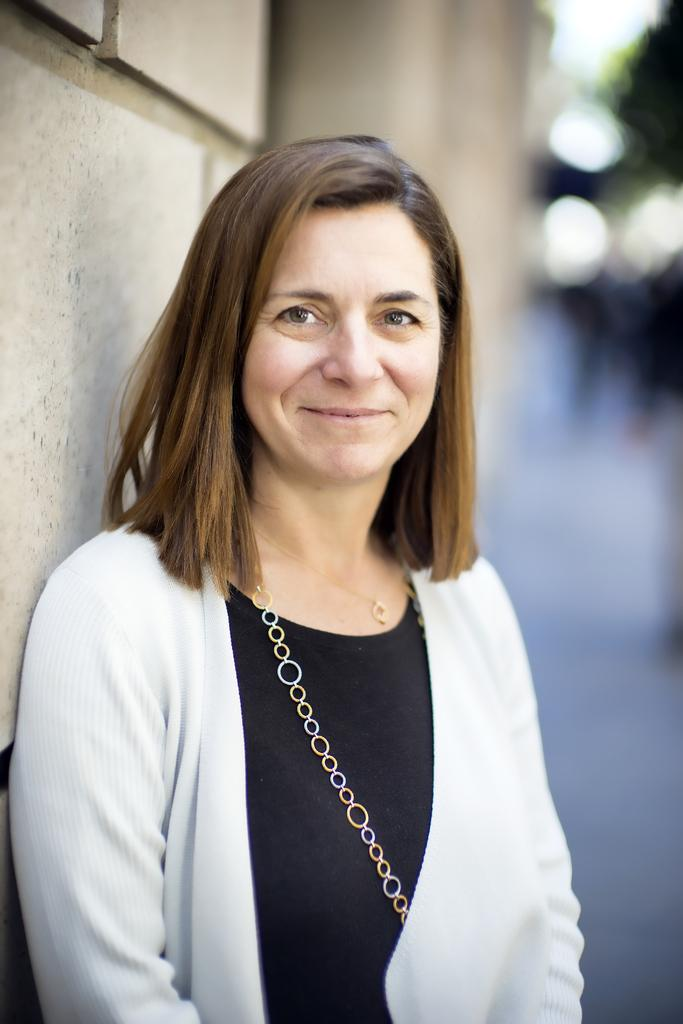What is the main subject in the foreground of the image? There is a woman standing on a road in the foreground of the image. What can be seen in the background of the image? There is a wall, a group of people, trees, and the sky visible in the background of the image. Can you describe the time of day when the image was taken? The image was taken during the day. Reasoning: Let' Let's think step by step in order to produce the conversation. We start by identifying the main subject in the foreground, which is the woman standing on the road. Then, we expand the conversation to include the various elements visible in the background, such as the wall, group of people, trees, and sky. Finally, we mention the time of day when the image was taken, which is during the day, based on the visible sky. Absurd Question/Answer: What type of writing can be seen on the woman's skin in the image? There is no writing visible on the woman's skin in the image. Which direction is the woman facing in relation to the north in the image? The image does not provide any information about the direction the woman is facing or the concept of north. 